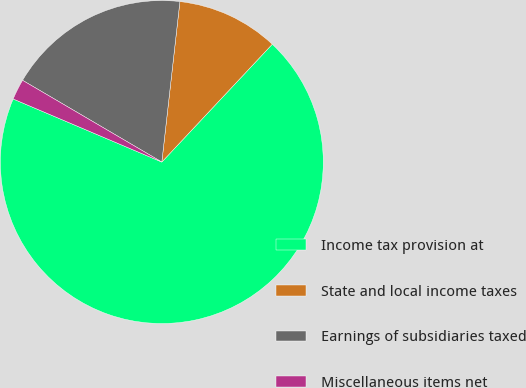Convert chart. <chart><loc_0><loc_0><loc_500><loc_500><pie_chart><fcel>Income tax provision at<fcel>State and local income taxes<fcel>Earnings of subsidiaries taxed<fcel>Miscellaneous items net<nl><fcel>69.4%<fcel>10.2%<fcel>18.34%<fcel>2.06%<nl></chart> 